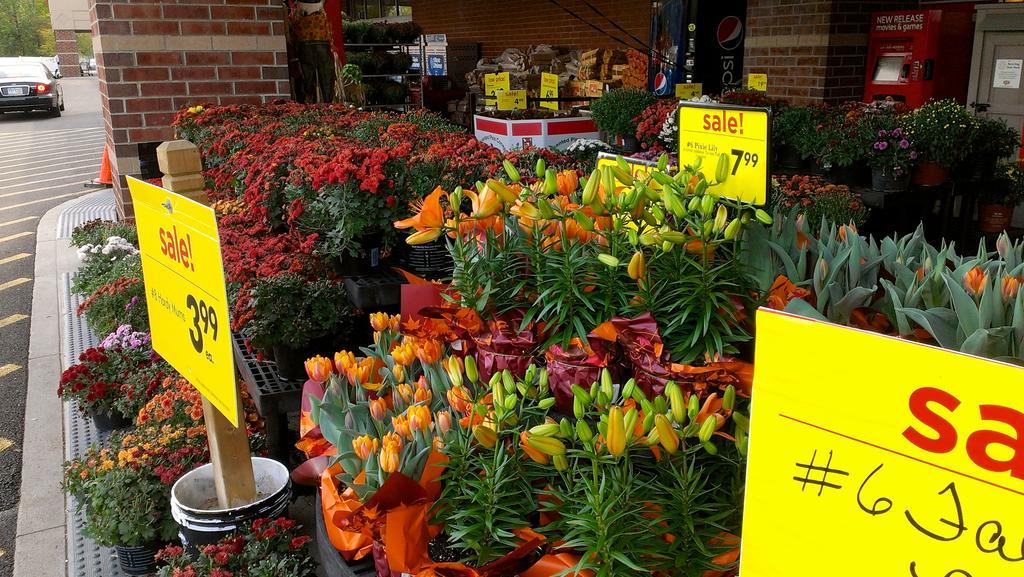In one or two sentences, can you explain what this image depicts? In this image we can see a group of houseplants and there are groups of flowers to the plants. In the middle of the plants there are a few boards with text. Behind the plants we can see a wall and a few objects. On the left side, we can see few vehicles and trees. 